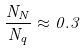Convert formula to latex. <formula><loc_0><loc_0><loc_500><loc_500>\frac { N _ { N } } { N _ { q } } \approx 0 . 3</formula> 